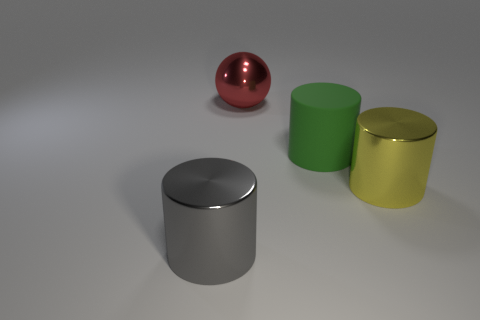Is there any other thing that is the same shape as the red shiny thing?
Your response must be concise. No. Are there more gray metallic cylinders left of the gray metallic thing than big yellow objects that are behind the sphere?
Your answer should be very brief. No. Is the yellow thing made of the same material as the large cylinder that is in front of the yellow metallic cylinder?
Provide a short and direct response. Yes. The shiny sphere is what color?
Offer a very short reply. Red. What shape is the metal object behind the big matte object?
Your answer should be very brief. Sphere. How many gray objects are large balls or big objects?
Provide a succinct answer. 1. There is a large sphere that is the same material as the yellow cylinder; what color is it?
Make the answer very short. Red. There is a sphere; is its color the same as the big thing that is to the right of the green object?
Your response must be concise. No. The object that is both left of the rubber cylinder and behind the yellow shiny cylinder is what color?
Offer a terse response. Red. What number of big matte cylinders are on the right side of the big rubber cylinder?
Provide a succinct answer. 0. 